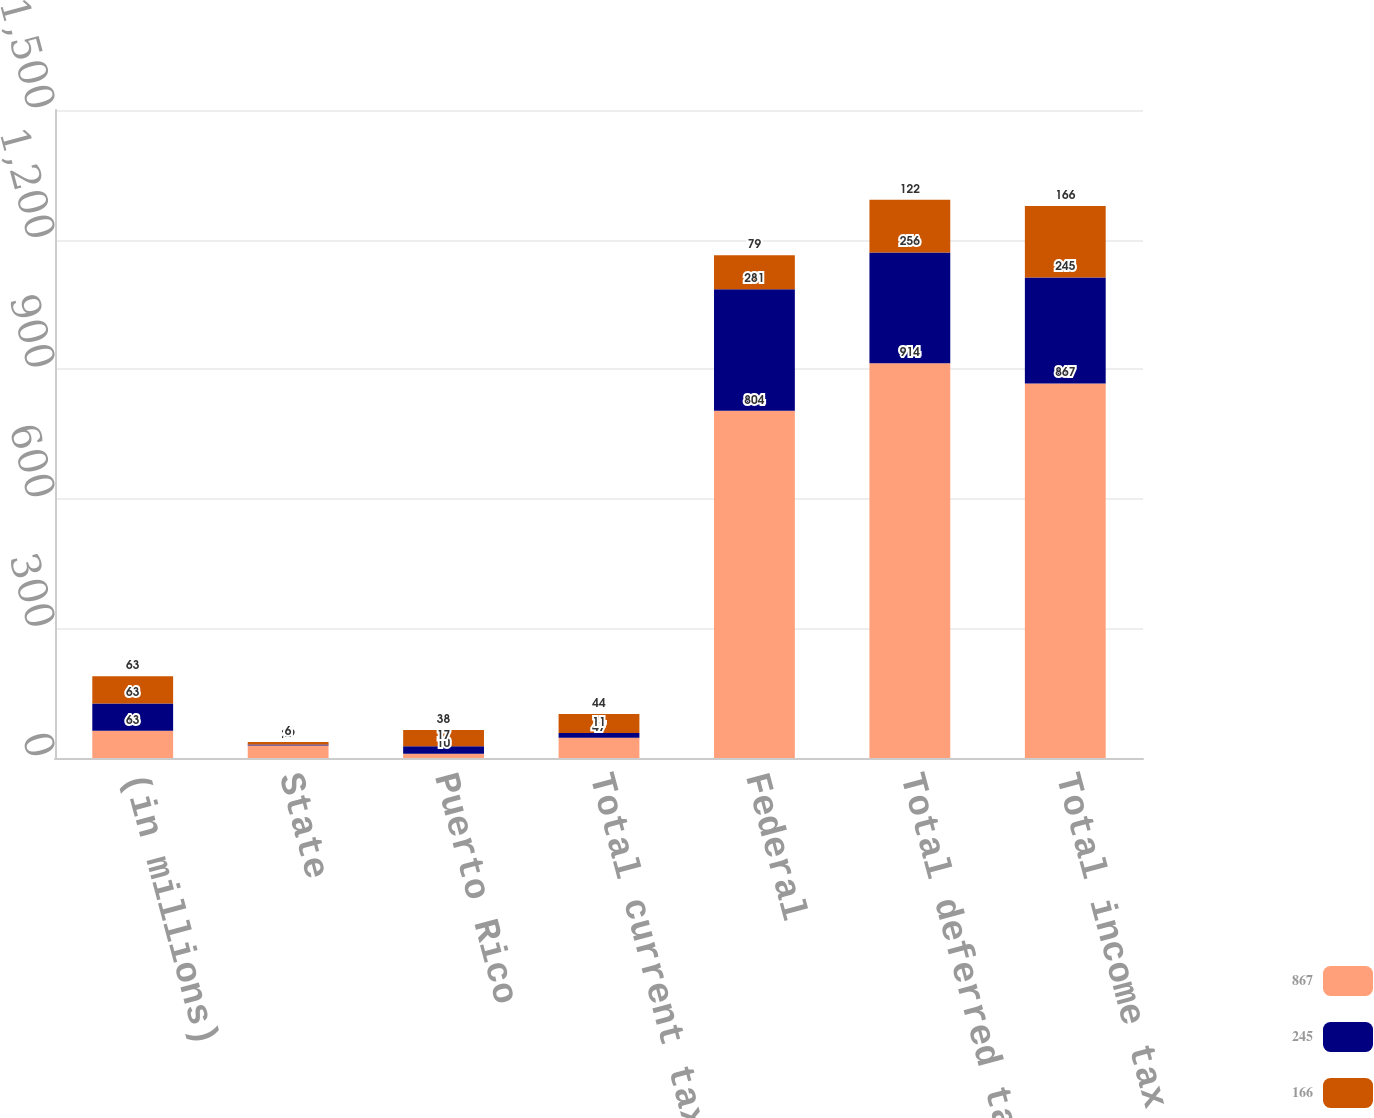Convert chart. <chart><loc_0><loc_0><loc_500><loc_500><stacked_bar_chart><ecel><fcel>(in millions)<fcel>State<fcel>Puerto Rico<fcel>Total current tax expense<fcel>Federal<fcel>Total deferred tax expense<fcel>Total income tax expense<nl><fcel>867<fcel>63<fcel>29<fcel>10<fcel>47<fcel>804<fcel>914<fcel>867<nl><fcel>245<fcel>63<fcel>2<fcel>17<fcel>11<fcel>281<fcel>256<fcel>245<nl><fcel>166<fcel>63<fcel>6<fcel>38<fcel>44<fcel>79<fcel>122<fcel>166<nl></chart> 